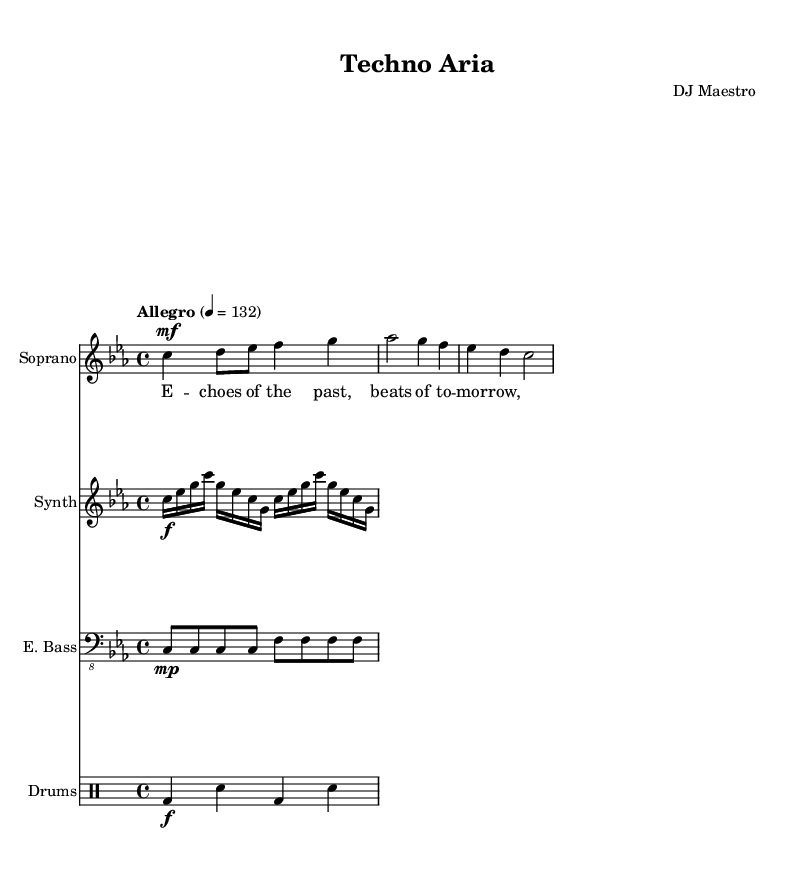What is the key signature of this music? The key signature indicated in the music is C minor, which includes three flats (B flat, E flat, and A flat).
Answer: C minor What is the time signature of the piece? The time signature shown in the music is 4/4, meaning there are four beats in a measure and the quarter note receives one beat.
Answer: 4/4 What is the tempo marking for this score? The tempo marking states "Allegro" with a metronome mark of 132, indicating a fast and lively tempo.
Answer: Allegro 4 = 132 Which instrument plays the highest pitch in this piece? The soprano voice, represented as the highest staff in the score, sings the highest pitches compared to the other instruments.
Answer: Soprano How many measures are in the soprano voice part? By counting the notes grouped within the lines and spaces of the soprano part, there are three measures present.
Answer: 3 What lyrics are associated with the choir part? The lyrics provided with the soprano part are "E -- choes of the past, beats of to -- mor -- row," which suggest themes of nostalgia and anticipation.
Answer: E -- choes of the past, beats of to -- mor -- row What is the role of the synthesizer in this score? The synthesizer plays rapidly repeating notes that form a melodic background, creating a lush texture that supports the soprano line.
Answer: Background texture 